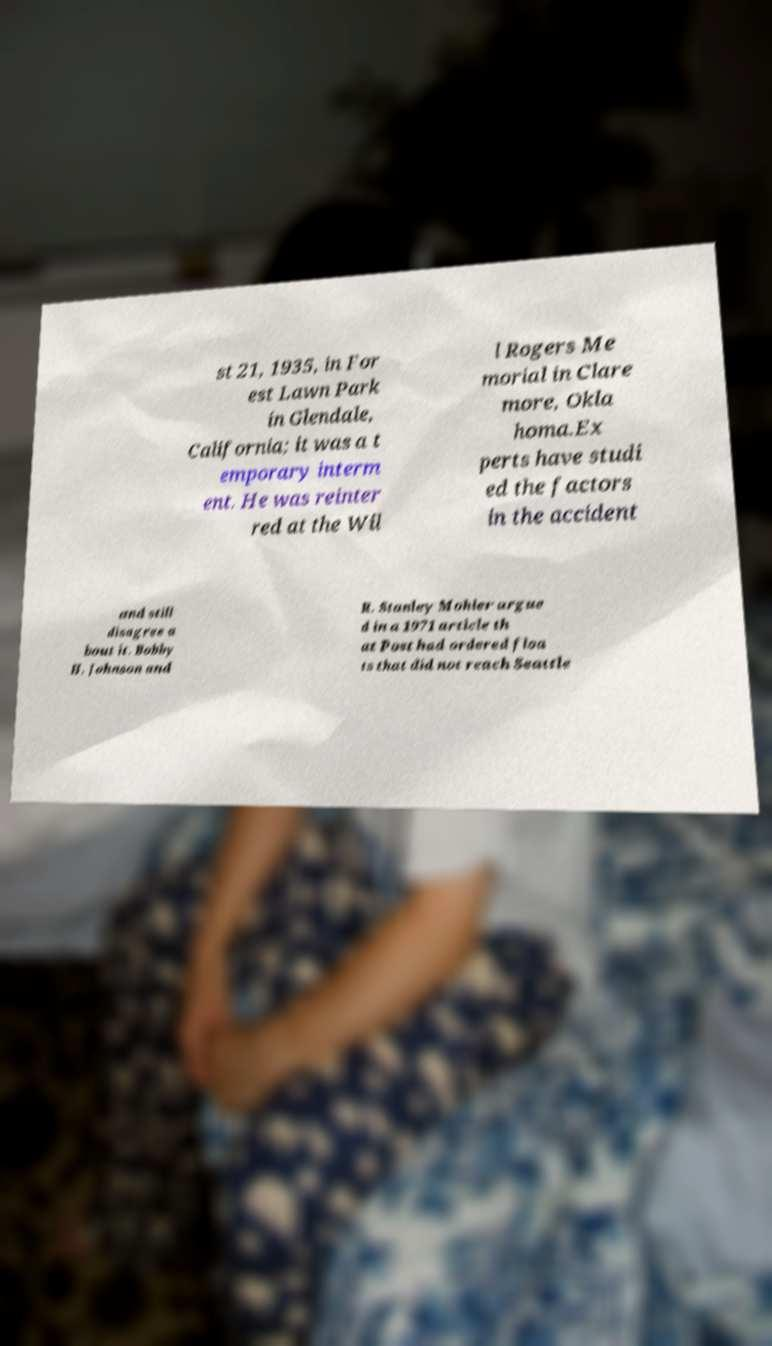For documentation purposes, I need the text within this image transcribed. Could you provide that? st 21, 1935, in For est Lawn Park in Glendale, California; it was a t emporary interm ent. He was reinter red at the Wil l Rogers Me morial in Clare more, Okla homa.Ex perts have studi ed the factors in the accident and still disagree a bout it. Bobby H. Johnson and R. Stanley Mohler argue d in a 1971 article th at Post had ordered floa ts that did not reach Seattle 